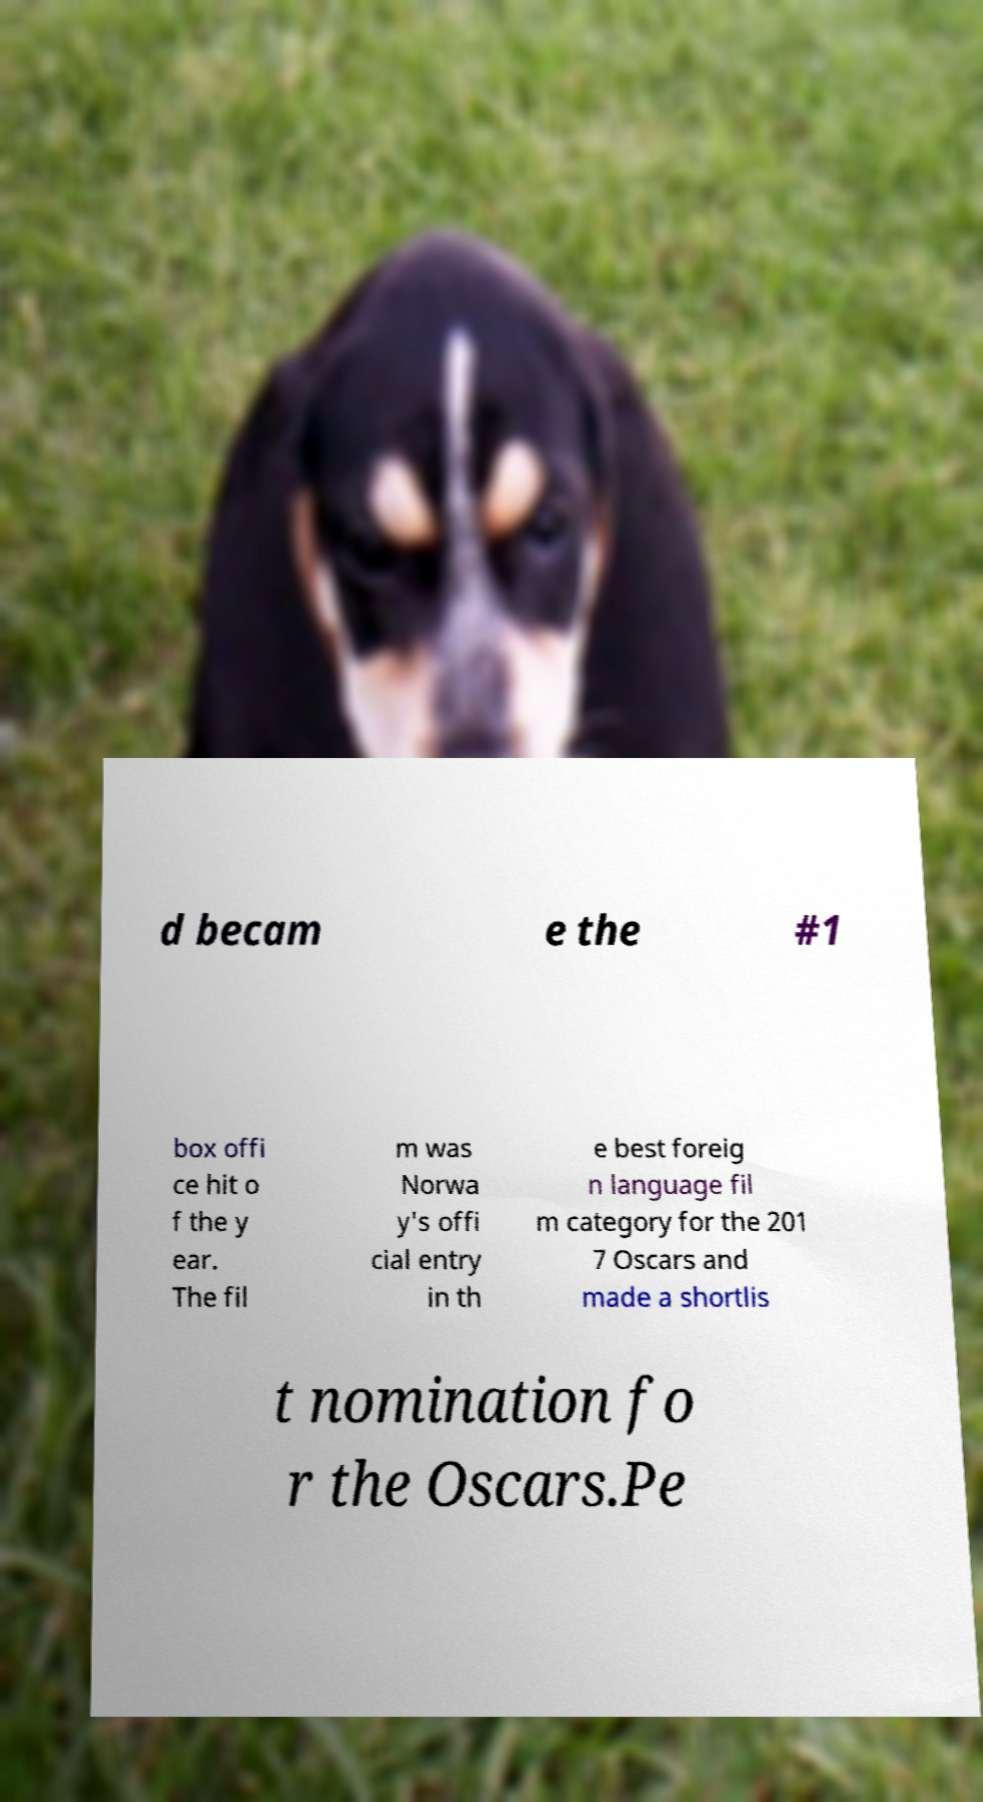Please read and relay the text visible in this image. What does it say? d becam e the #1 box offi ce hit o f the y ear. The fil m was Norwa y's offi cial entry in th e best foreig n language fil m category for the 201 7 Oscars and made a shortlis t nomination fo r the Oscars.Pe 